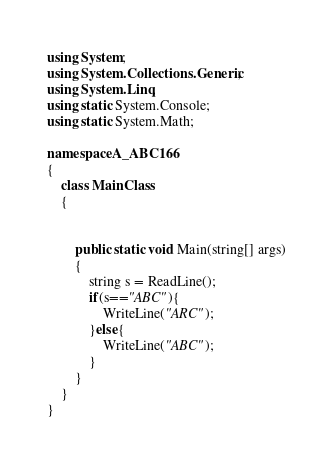<code> <loc_0><loc_0><loc_500><loc_500><_C#_>using System;
using System.Collections.Generic;
using System.Linq;
using static System.Console;
using static System.Math;

namespace A_ABC166
{
    class MainClass
    {


        public static void Main(string[] args)
        {
            string s = ReadLine();
            if(s=="ABC"){
                WriteLine("ARC");
            }else{
                WriteLine("ABC");
            }
        }
    }
}
</code> 